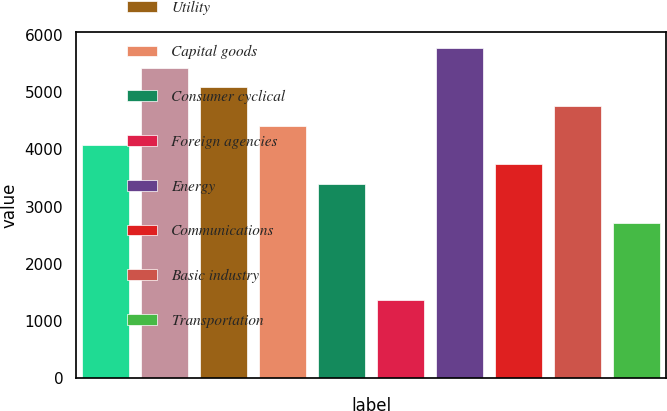Convert chart. <chart><loc_0><loc_0><loc_500><loc_500><bar_chart><fcel>Finance<fcel>Consumer non-cyclical<fcel>Utility<fcel>Capital goods<fcel>Consumer cyclical<fcel>Foreign agencies<fcel>Energy<fcel>Communications<fcel>Basic industry<fcel>Transportation<nl><fcel>4076.4<fcel>5433.2<fcel>5094<fcel>4415.6<fcel>3398<fcel>1362.8<fcel>5772.4<fcel>3737.2<fcel>4754.8<fcel>2719.6<nl></chart> 